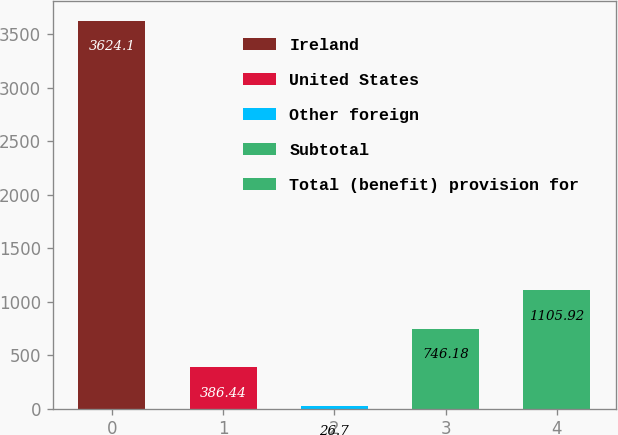Convert chart to OTSL. <chart><loc_0><loc_0><loc_500><loc_500><bar_chart><fcel>Ireland<fcel>United States<fcel>Other foreign<fcel>Subtotal<fcel>Total (benefit) provision for<nl><fcel>3624.1<fcel>386.44<fcel>26.7<fcel>746.18<fcel>1105.92<nl></chart> 